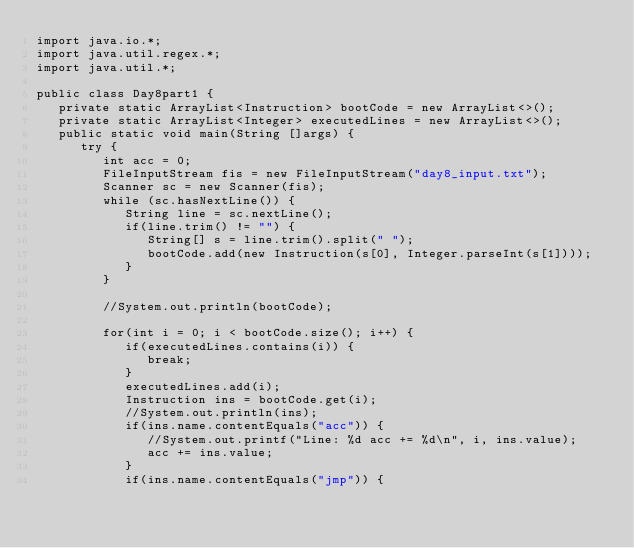<code> <loc_0><loc_0><loc_500><loc_500><_Java_>import java.io.*;
import java.util.regex.*;
import java.util.*;

public class Day8part1 {
   private static ArrayList<Instruction> bootCode = new ArrayList<>();
   private static ArrayList<Integer> executedLines = new ArrayList<>();
   public static void main(String []args) {
      try {
         int acc = 0;
         FileInputStream fis = new FileInputStream("day8_input.txt");
         Scanner sc = new Scanner(fis);
         while (sc.hasNextLine()) {
            String line = sc.nextLine();
            if(line.trim() != "") {
               String[] s = line.trim().split(" ");
               bootCode.add(new Instruction(s[0], Integer.parseInt(s[1])));
            }
         }

         //System.out.println(bootCode);

         for(int i = 0; i < bootCode.size(); i++) {
            if(executedLines.contains(i)) {
               break;
            }
            executedLines.add(i);
            Instruction ins = bootCode.get(i);
            //System.out.println(ins);
            if(ins.name.contentEquals("acc")) {
               //System.out.printf("Line: %d acc += %d\n", i, ins.value);
               acc += ins.value;
            }
            if(ins.name.contentEquals("jmp")) {</code> 